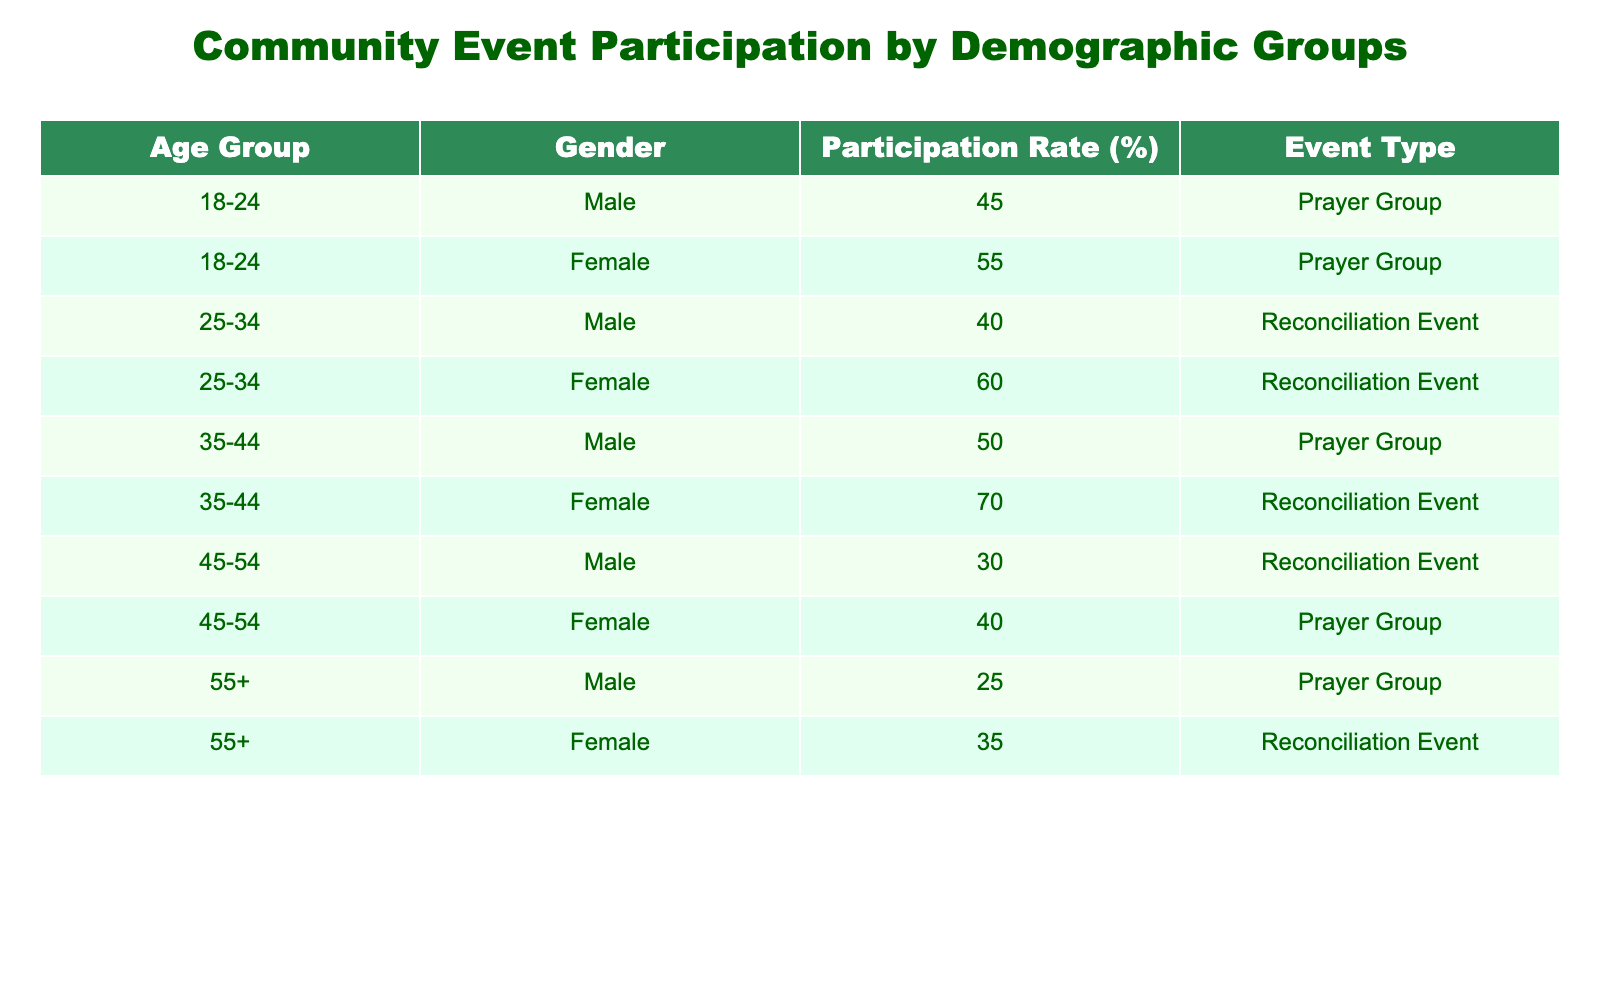What is the participation rate for females in the Prayer Group aged 18-24? The table shows that for females in the 18-24 age group, the participation rate is 55%.
Answer: 55 What is the highest participation rate in the Reconciliation Event category? In the table, the highest participation rate for Reconciliation Events is 60%, which is for females aged 25-34.
Answer: 60 Is the participation rate for males aged 45-54 higher in the Prayer Group or the Reconciliation Event? For males aged 45-54, the participation rate is 30% for Reconciliation Events and 40% for Prayer Groups. Since 40% is higher, Prayer Group has the higher rate.
Answer: Yes What is the average participation rate for males across all age groups in Prayer Groups? The participation rates for males in Prayer Groups are 45%, 50%, and 25% for age groups 18-24, 35-44, and 55+. To calculate the average: (45 + 50 + 25) / 3 = 120 / 3 = 40%.
Answer: 40% What is the difference in participation rates between females and males in the 35-44 age group for Reconciliation Events? For females aged 35-44, the participation rate is 70%, while for males it is 50%. The difference is 70% - 50% = 20%.
Answer: 20% Is it true that the participation rate for all age groups combined is higher for females than for males in Prayer Groups? By looking at the rates for Prayer Groups, females have higher rates of 55%, 70%, and 40% while males have 45%, 50%, and 25%. The totals indicate female participation is 165%, and male participation is 115%, thereby confirming the statement.
Answer: Yes Which age group has the lowest participation rate in the Reconciliation Event? The table indicates that the lowest participation rate for Reconciliation Events is 30%, which is for males aged 45-54.
Answer: 30% What is the total participation rate for females in all events combined? Summing the participation rates for females across all events and age groups gives: 55% (18-24 Prayer) + 60% (25-34 Reconciliation) + 70% (35-44 Reconciliation) + 40% (45-54 Prayer) + 35% (55+ Reconciliation) = 55 + 60 + 70 + 40 + 35 = 260%. Therefore, the total is 260%.
Answer: 260% What is the participation rate of males aged 55 and older in Prayer Groups? Looking at the table, the participation rate for males in the 55+ age group for Prayer Groups is 25%.
Answer: 25% 